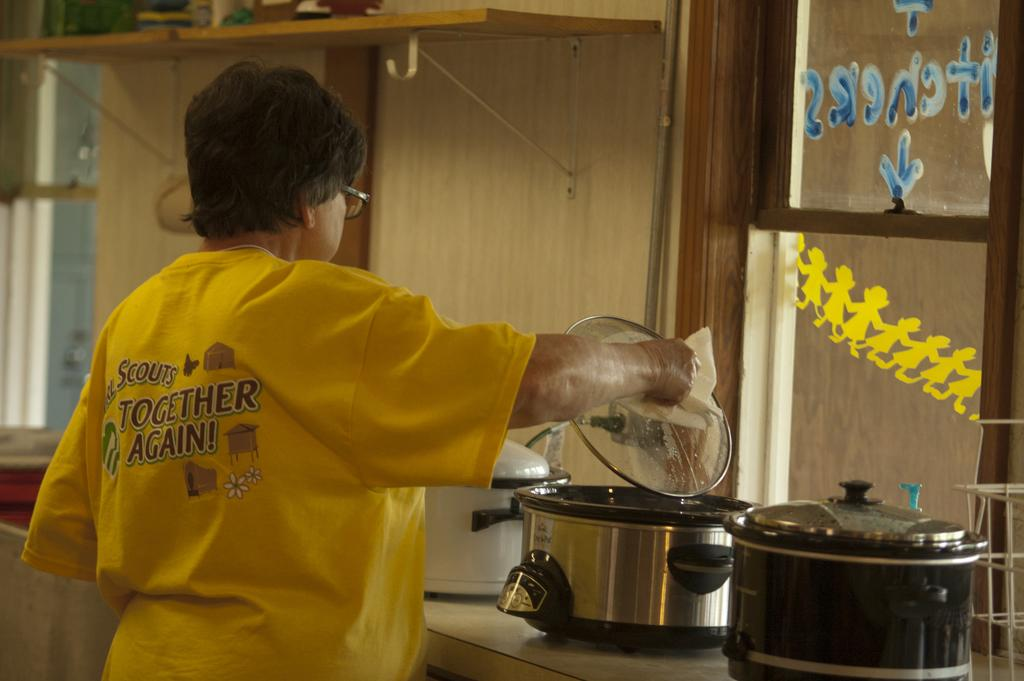<image>
Provide a brief description of the given image. A person with a shirt that says Together Again 